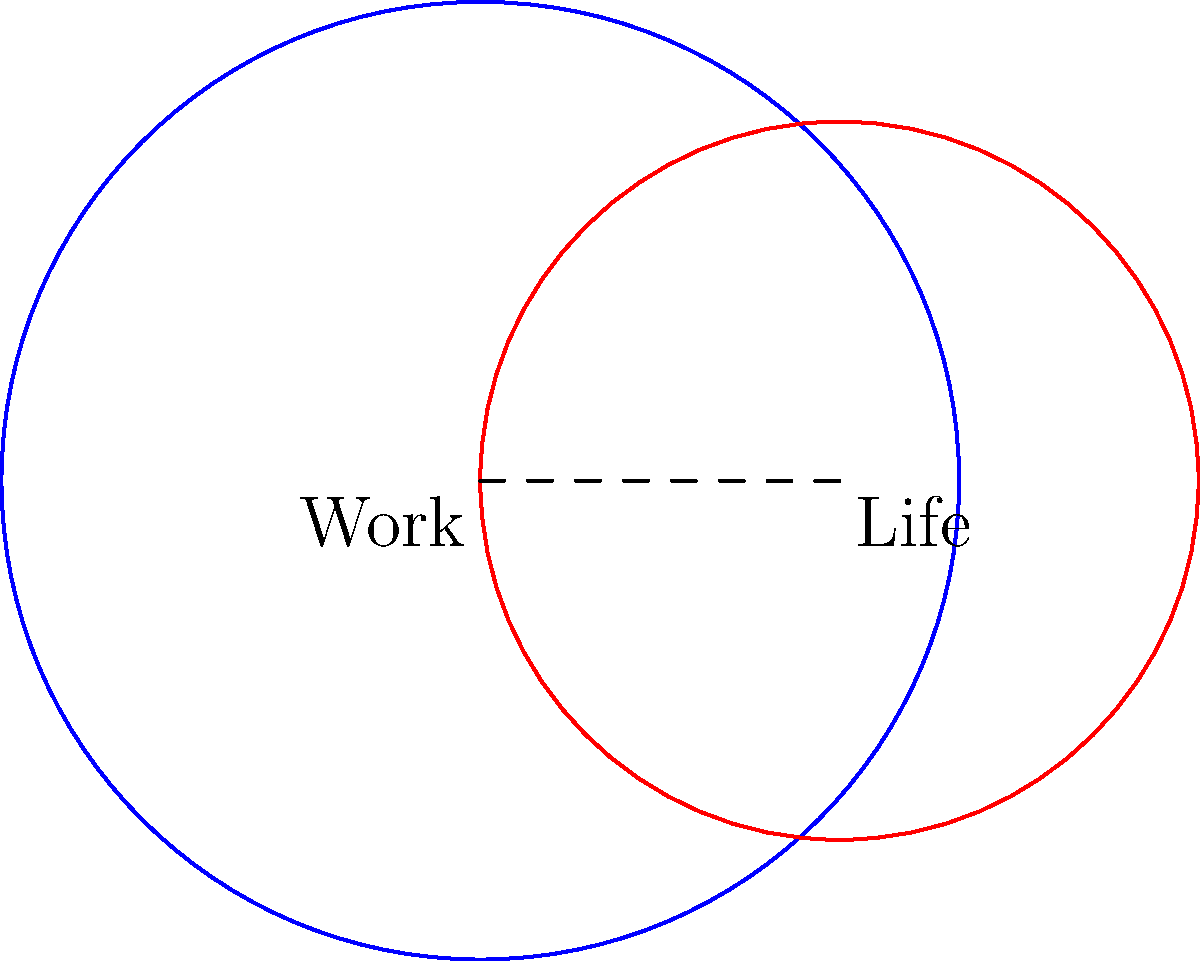In the diagram, two circles represent the balance between work and personal life. The blue circle (work) has a radius of 2 units, while the red circle (life) has a radius of 1.5 units. The centers of the circles are 1.5 units apart. Calculate the area of the overlapping region, which symbolizes the integration of work and life. Round your answer to two decimal places. To solve this problem, we'll use the formula for the area of overlapping circles:

1) First, calculate the distance between the centers (d):
   $d = 1.5$ (given)

2) The radii are: $r_1 = 2$ and $r_2 = 1.5$

3) Use the formula for the area of the overlap (A):
   $$A = r_1^2 \arccos(\frac{d^2 + r_1^2 - r_2^2}{2dr_1}) + r_2^2 \arccos(\frac{d^2 + r_2^2 - r_1^2}{2dr_2}) - \frac{1}{2}\sqrt{(-d+r_1+r_2)(d+r_1-r_2)(d-r_1+r_2)(d+r_1+r_2)}$$

4) Substitute the values:
   $$A = 2^2 \arccos(\frac{1.5^2 + 2^2 - 1.5^2}{2 \cdot 1.5 \cdot 2}) + 1.5^2 \arccos(\frac{1.5^2 + 1.5^2 - 2^2}{2 \cdot 1.5 \cdot 1.5}) - \frac{1}{2}\sqrt{(-1.5+2+1.5)(1.5+2-1.5)(1.5-2+1.5)(1.5+2+1.5)}$$

5) Simplify and calculate:
   $$A = 4 \arccos(0.71875) + 2.25 \arccos(-0.083333) - 0.5\sqrt{2 \cdot 2 \cdot 1 \cdot 5}$$
   $$A \approx 3.145829 + 3.534255 - 2.236068$$
   $$A \approx 4.44$$

6) Round to two decimal places: 4.44 square units
Answer: 4.44 square units 